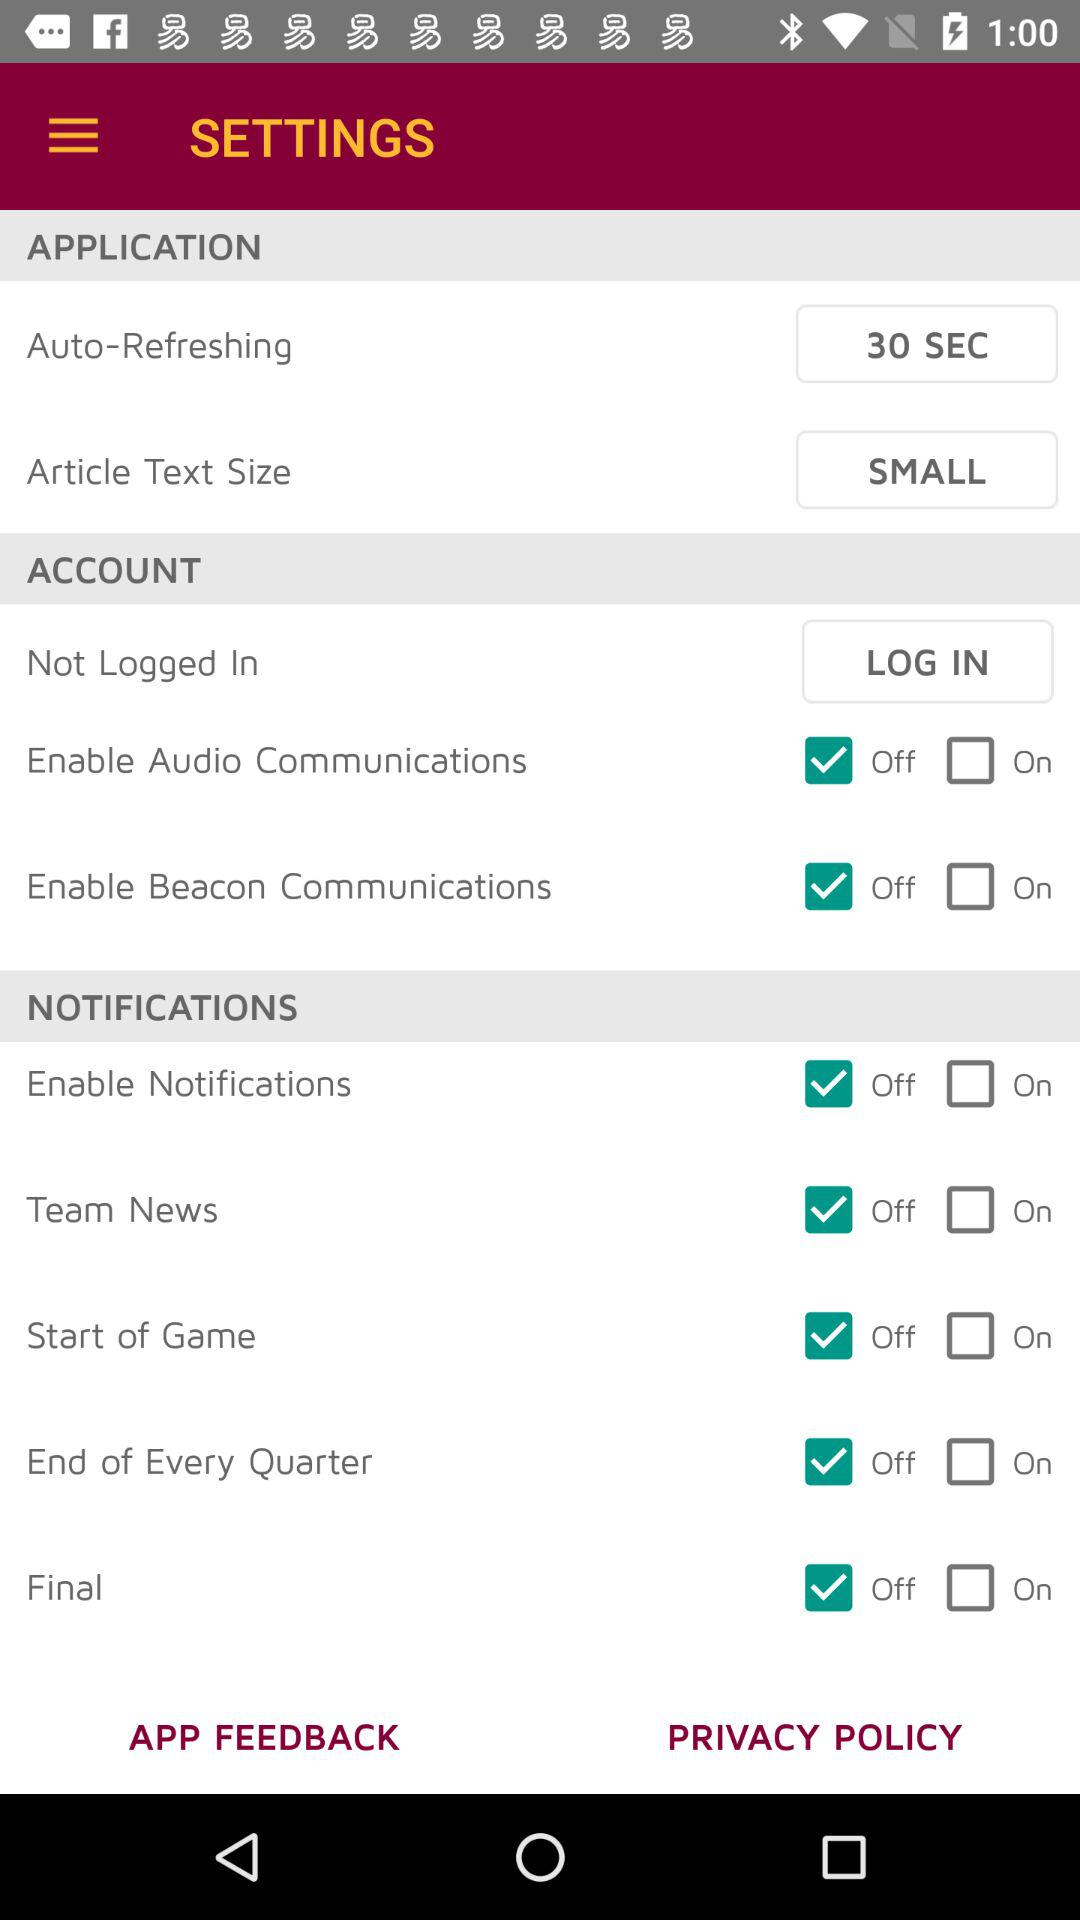What is the status of "Start of Game"? The status is "off". 